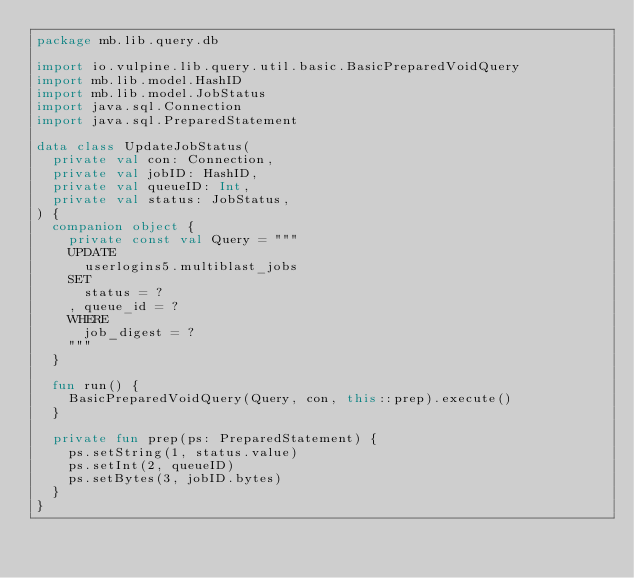Convert code to text. <code><loc_0><loc_0><loc_500><loc_500><_Kotlin_>package mb.lib.query.db

import io.vulpine.lib.query.util.basic.BasicPreparedVoidQuery
import mb.lib.model.HashID
import mb.lib.model.JobStatus
import java.sql.Connection
import java.sql.PreparedStatement

data class UpdateJobStatus(
  private val con: Connection,
  private val jobID: HashID,
  private val queueID: Int,
  private val status: JobStatus,
) {
  companion object {
    private const val Query = """
    UPDATE
      userlogins5.multiblast_jobs
    SET
      status = ?
    , queue_id = ?
    WHERE
      job_digest = ?
    """
  }

  fun run() {
    BasicPreparedVoidQuery(Query, con, this::prep).execute()
  }

  private fun prep(ps: PreparedStatement) {
    ps.setString(1, status.value)
    ps.setInt(2, queueID)
    ps.setBytes(3, jobID.bytes)
  }
}
</code> 